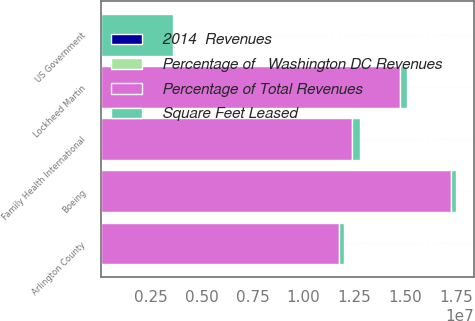<chart> <loc_0><loc_0><loc_500><loc_500><stacked_bar_chart><ecel><fcel>US Government<fcel>Boeing<fcel>Lockheed Martin<fcel>Family Health International<fcel>Arlington County<nl><fcel>Square Feet Leased<fcel>3.576e+06<fcel>253000<fcel>329000<fcel>359000<fcel>241000<nl><fcel>Percentage of Total Revenues<fcel>24.8<fcel>1.7249e+07<fcel>1.4755e+07<fcel>1.2407e+07<fcel>1.1728e+07<nl><fcel>Percentage of   Washington DC Revenues<fcel>24.8<fcel>3.2<fcel>2.8<fcel>2.3<fcel>2.2<nl><fcel>2014  Revenues<fcel>5<fcel>0.7<fcel>0.6<fcel>0.5<fcel>0.4<nl></chart> 